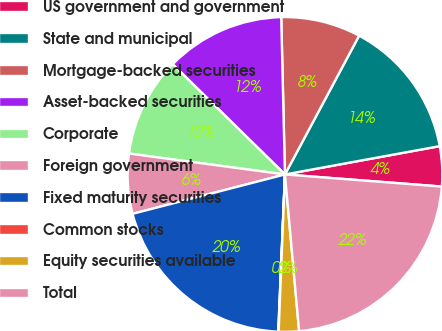Convert chart to OTSL. <chart><loc_0><loc_0><loc_500><loc_500><pie_chart><fcel>US government and government<fcel>State and municipal<fcel>Mortgage-backed securities<fcel>Asset-backed securities<fcel>Corporate<fcel>Foreign government<fcel>Fixed maturity securities<fcel>Common stocks<fcel>Equity securities available<fcel>Total<nl><fcel>4.11%<fcel>14.31%<fcel>8.19%<fcel>12.27%<fcel>10.23%<fcel>6.15%<fcel>20.3%<fcel>0.04%<fcel>2.07%<fcel>22.34%<nl></chart> 